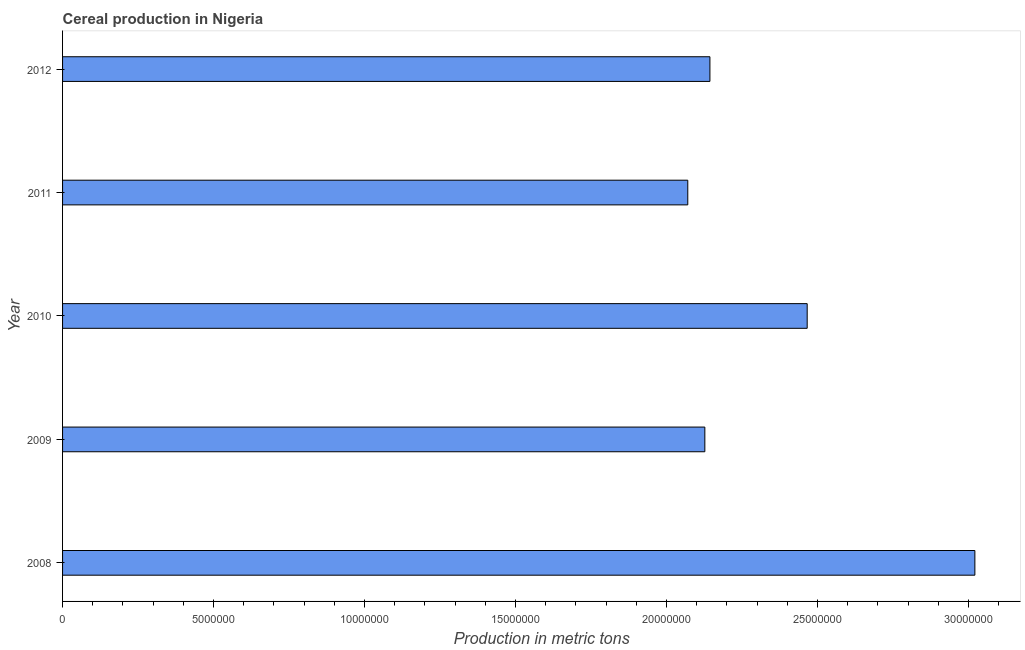Does the graph contain grids?
Offer a terse response. No. What is the title of the graph?
Your answer should be very brief. Cereal production in Nigeria. What is the label or title of the X-axis?
Give a very brief answer. Production in metric tons. What is the label or title of the Y-axis?
Provide a short and direct response. Year. What is the cereal production in 2012?
Your answer should be compact. 2.14e+07. Across all years, what is the maximum cereal production?
Give a very brief answer. 3.02e+07. Across all years, what is the minimum cereal production?
Offer a very short reply. 2.07e+07. What is the sum of the cereal production?
Make the answer very short. 1.18e+08. What is the difference between the cereal production in 2010 and 2012?
Offer a very short reply. 3.22e+06. What is the average cereal production per year?
Make the answer very short. 2.37e+07. What is the median cereal production?
Your answer should be compact. 2.14e+07. What is the ratio of the cereal production in 2009 to that in 2012?
Provide a short and direct response. 0.99. What is the difference between the highest and the second highest cereal production?
Your answer should be very brief. 5.55e+06. What is the difference between the highest and the lowest cereal production?
Give a very brief answer. 9.51e+06. In how many years, is the cereal production greater than the average cereal production taken over all years?
Offer a very short reply. 2. Are all the bars in the graph horizontal?
Your response must be concise. Yes. What is the difference between two consecutive major ticks on the X-axis?
Offer a very short reply. 5.00e+06. What is the Production in metric tons of 2008?
Give a very brief answer. 3.02e+07. What is the Production in metric tons in 2009?
Your response must be concise. 2.13e+07. What is the Production in metric tons of 2010?
Give a very brief answer. 2.47e+07. What is the Production in metric tons of 2011?
Your answer should be compact. 2.07e+07. What is the Production in metric tons in 2012?
Provide a succinct answer. 2.14e+07. What is the difference between the Production in metric tons in 2008 and 2009?
Keep it short and to the point. 8.94e+06. What is the difference between the Production in metric tons in 2008 and 2010?
Your answer should be very brief. 5.55e+06. What is the difference between the Production in metric tons in 2008 and 2011?
Your answer should be compact. 9.51e+06. What is the difference between the Production in metric tons in 2008 and 2012?
Provide a short and direct response. 8.77e+06. What is the difference between the Production in metric tons in 2009 and 2010?
Provide a succinct answer. -3.39e+06. What is the difference between the Production in metric tons in 2009 and 2011?
Provide a succinct answer. 5.65e+05. What is the difference between the Production in metric tons in 2009 and 2012?
Ensure brevity in your answer.  -1.68e+05. What is the difference between the Production in metric tons in 2010 and 2011?
Ensure brevity in your answer.  3.95e+06. What is the difference between the Production in metric tons in 2010 and 2012?
Your response must be concise. 3.22e+06. What is the difference between the Production in metric tons in 2011 and 2012?
Your response must be concise. -7.33e+05. What is the ratio of the Production in metric tons in 2008 to that in 2009?
Ensure brevity in your answer.  1.42. What is the ratio of the Production in metric tons in 2008 to that in 2010?
Your answer should be compact. 1.23. What is the ratio of the Production in metric tons in 2008 to that in 2011?
Provide a short and direct response. 1.46. What is the ratio of the Production in metric tons in 2008 to that in 2012?
Offer a terse response. 1.41. What is the ratio of the Production in metric tons in 2009 to that in 2010?
Your response must be concise. 0.86. What is the ratio of the Production in metric tons in 2010 to that in 2011?
Offer a terse response. 1.19. What is the ratio of the Production in metric tons in 2010 to that in 2012?
Give a very brief answer. 1.15. What is the ratio of the Production in metric tons in 2011 to that in 2012?
Offer a terse response. 0.97. 